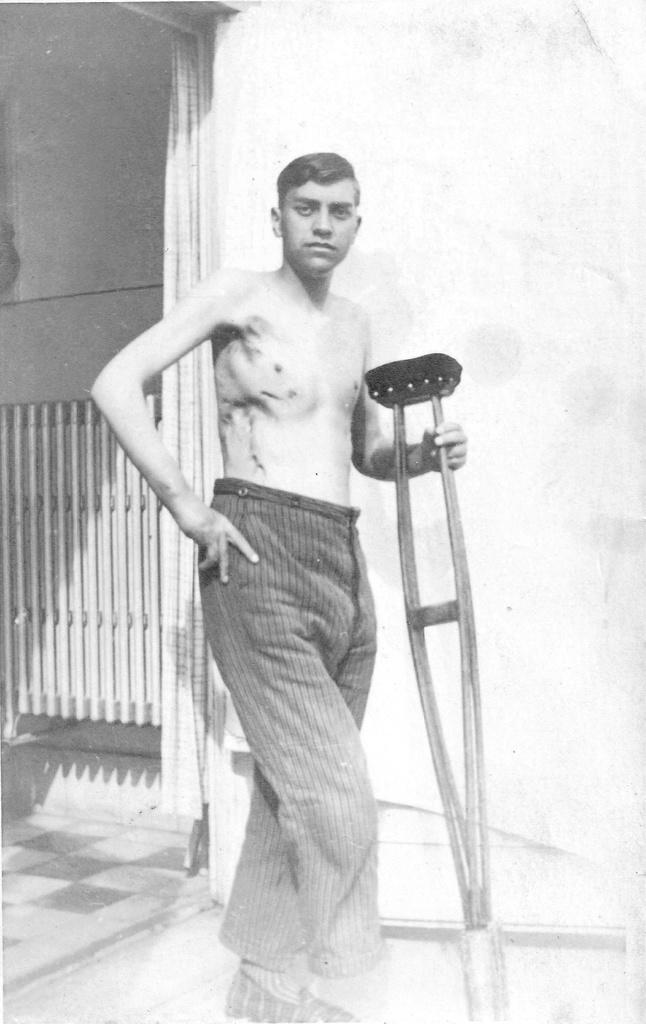What is the main subject of the image? There is a person standing in the center of the image. What is the person holding in the image? The person is holding a stick. What can be seen in the background of the image? There is a wall and a gate in the background of the image. What is visible at the bottom of the image? There is a floor visible at the bottom of the image. What type of spot can be seen on the person's shirt in the image? There is no spot visible on the person's shirt in the image. What shape is the square that the person is standing on in the image? There is no square visible in the image; the person is standing on a floor. 